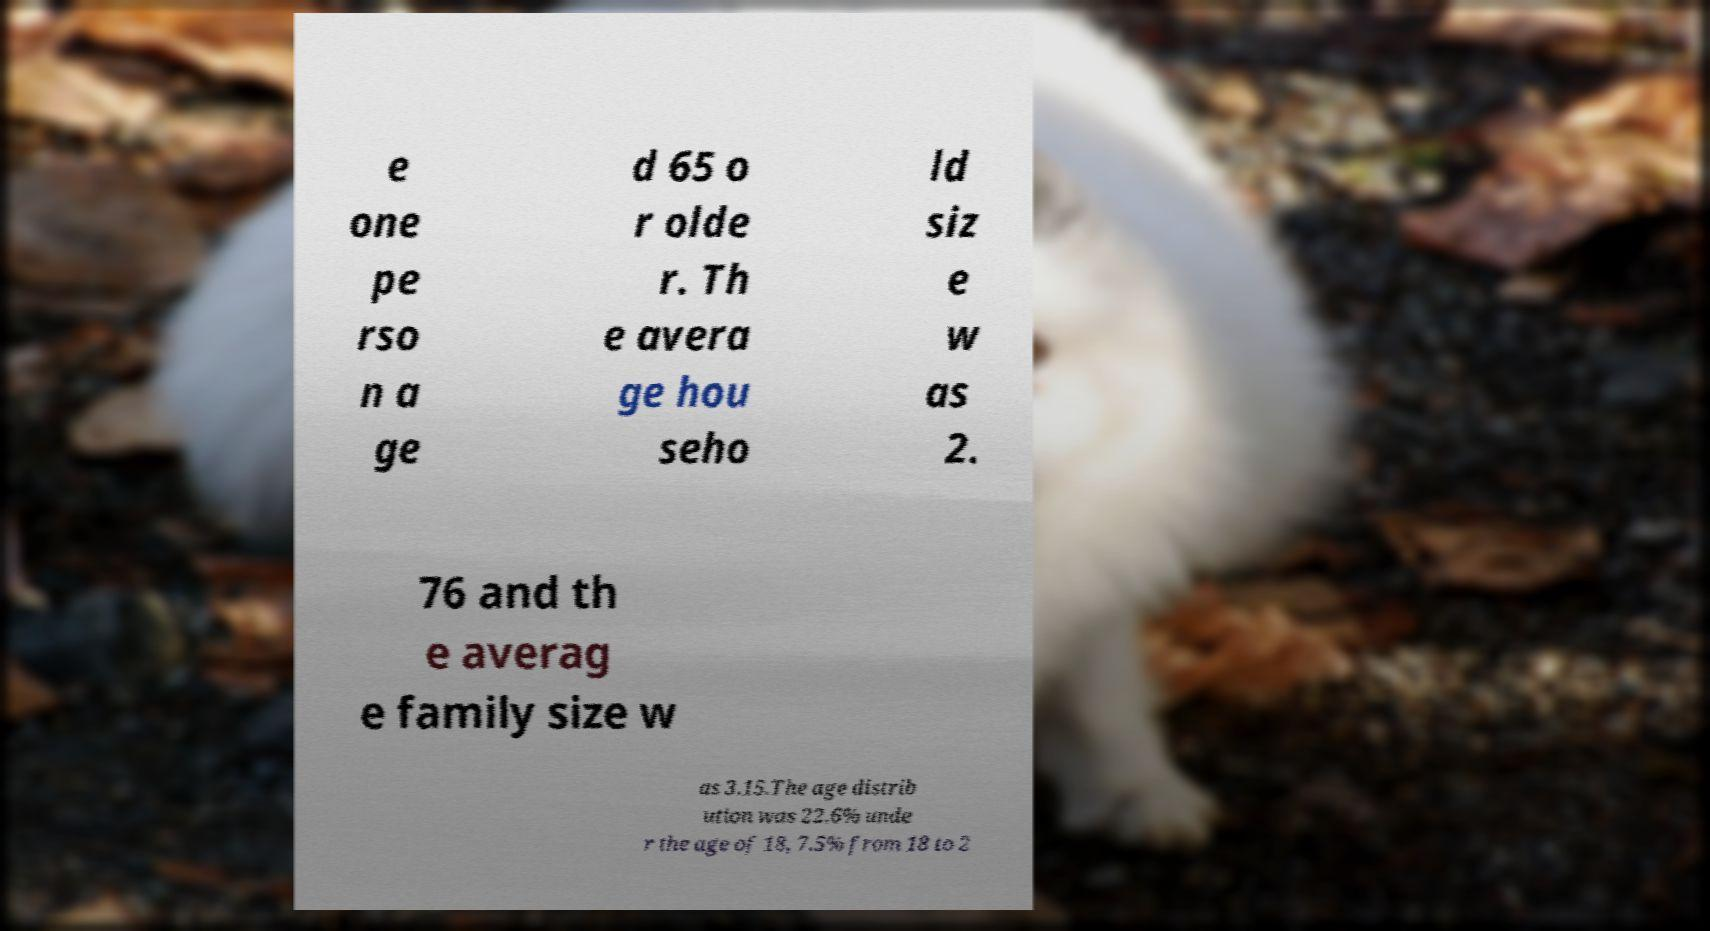There's text embedded in this image that I need extracted. Can you transcribe it verbatim? e one pe rso n a ge d 65 o r olde r. Th e avera ge hou seho ld siz e w as 2. 76 and th e averag e family size w as 3.15.The age distrib ution was 22.6% unde r the age of 18, 7.5% from 18 to 2 